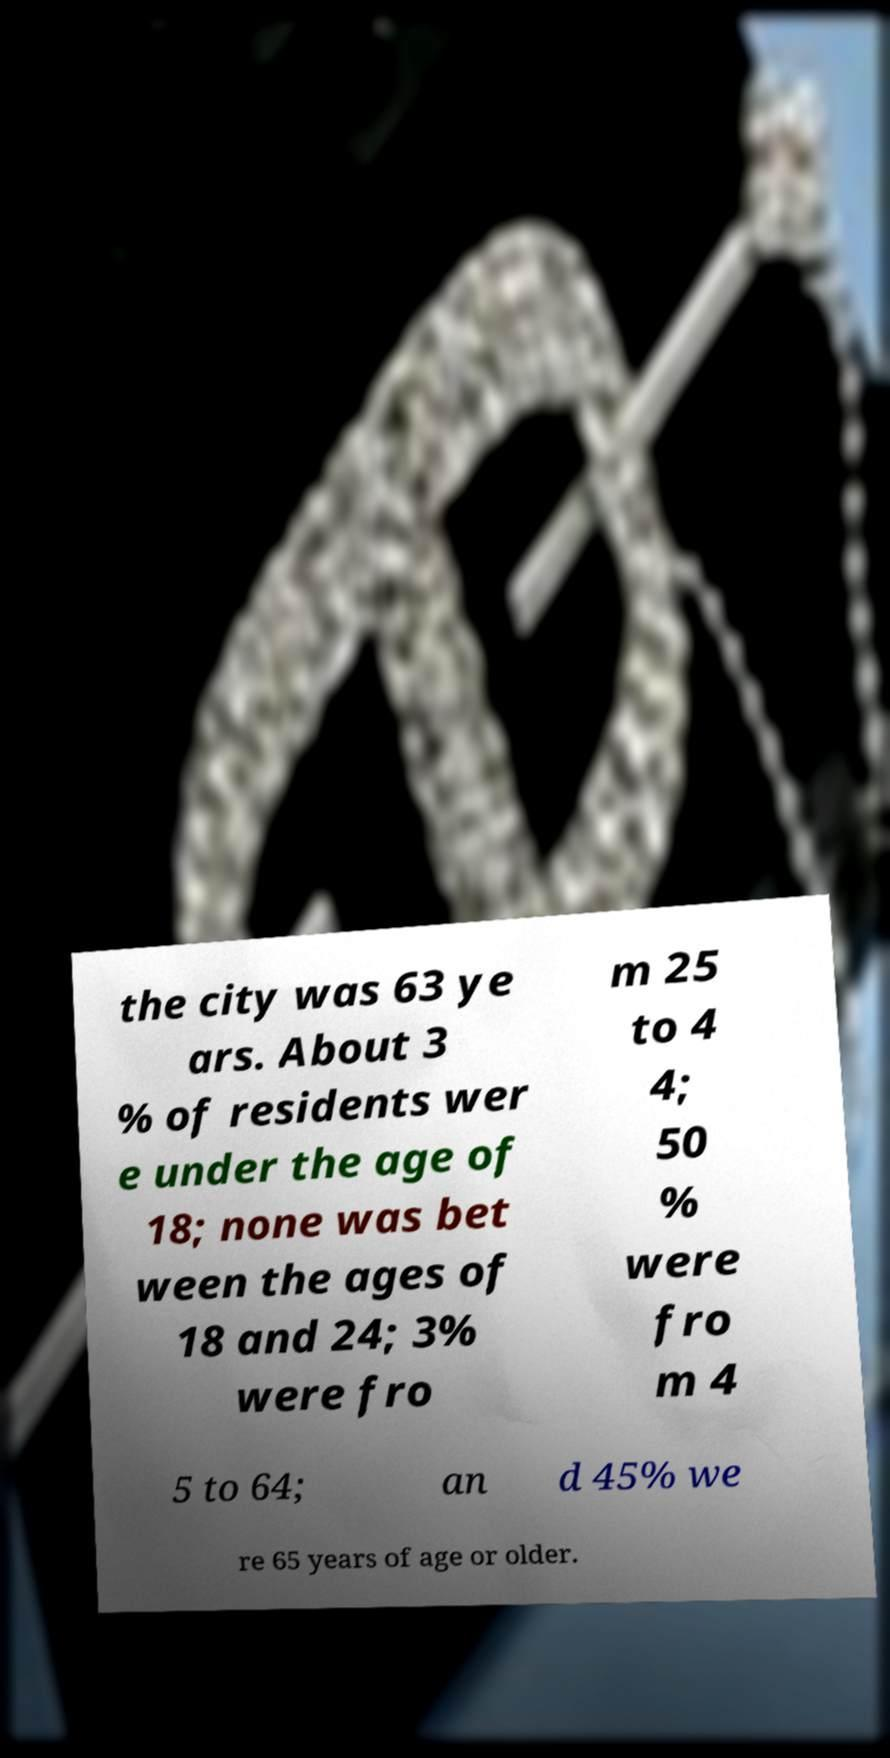Please identify and transcribe the text found in this image. the city was 63 ye ars. About 3 % of residents wer e under the age of 18; none was bet ween the ages of 18 and 24; 3% were fro m 25 to 4 4; 50 % were fro m 4 5 to 64; an d 45% we re 65 years of age or older. 